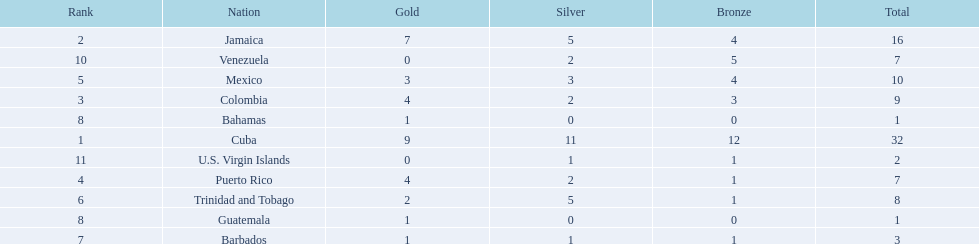Which nations played in the games? Cuba, Jamaica, Colombia, Puerto Rico, Mexico, Trinidad and Tobago, Barbados, Guatemala, Bahamas, Venezuela, U.S. Virgin Islands. How many silver medals did they win? 11, 5, 2, 2, 3, 5, 1, 0, 0, 2, 1. Which team won the most silver? Cuba. 